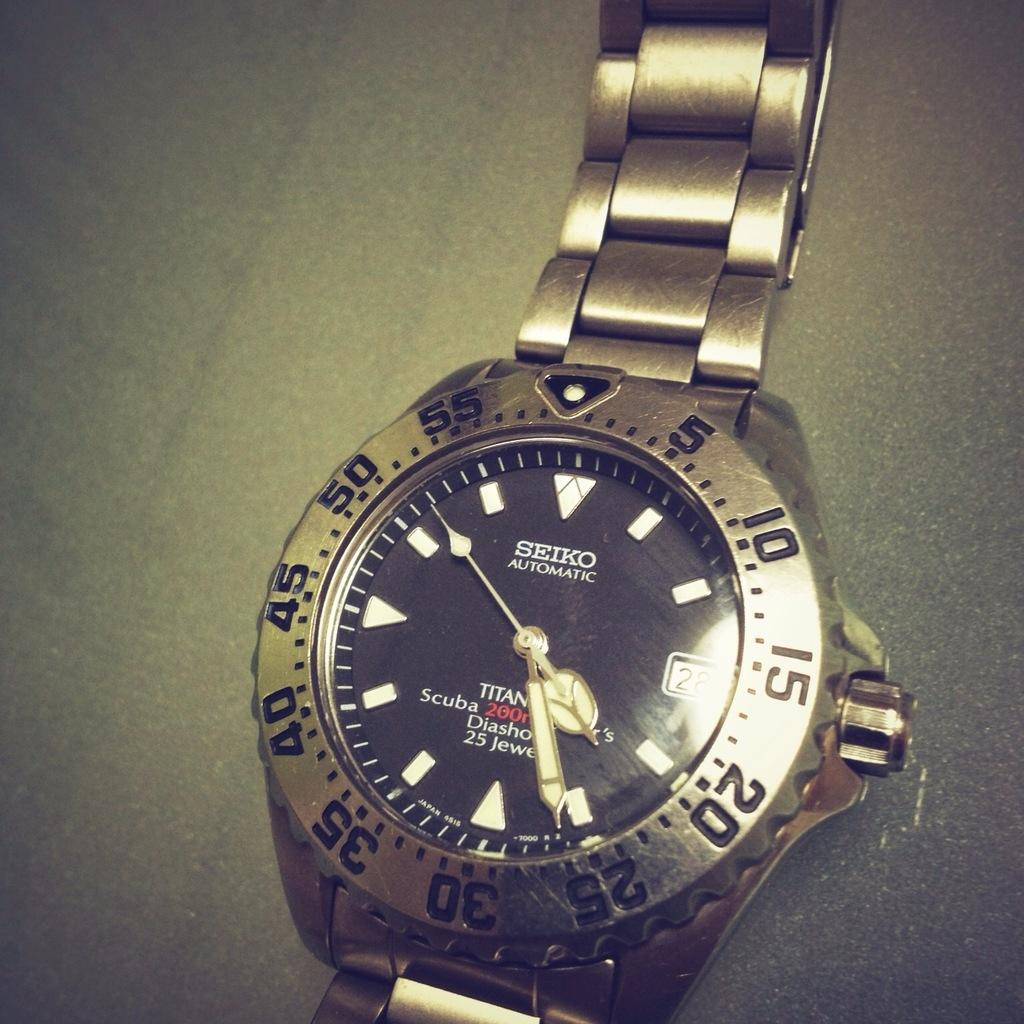Provide a one-sentence caption for the provided image. A Siko automatic watch shows the time as 4:26. 